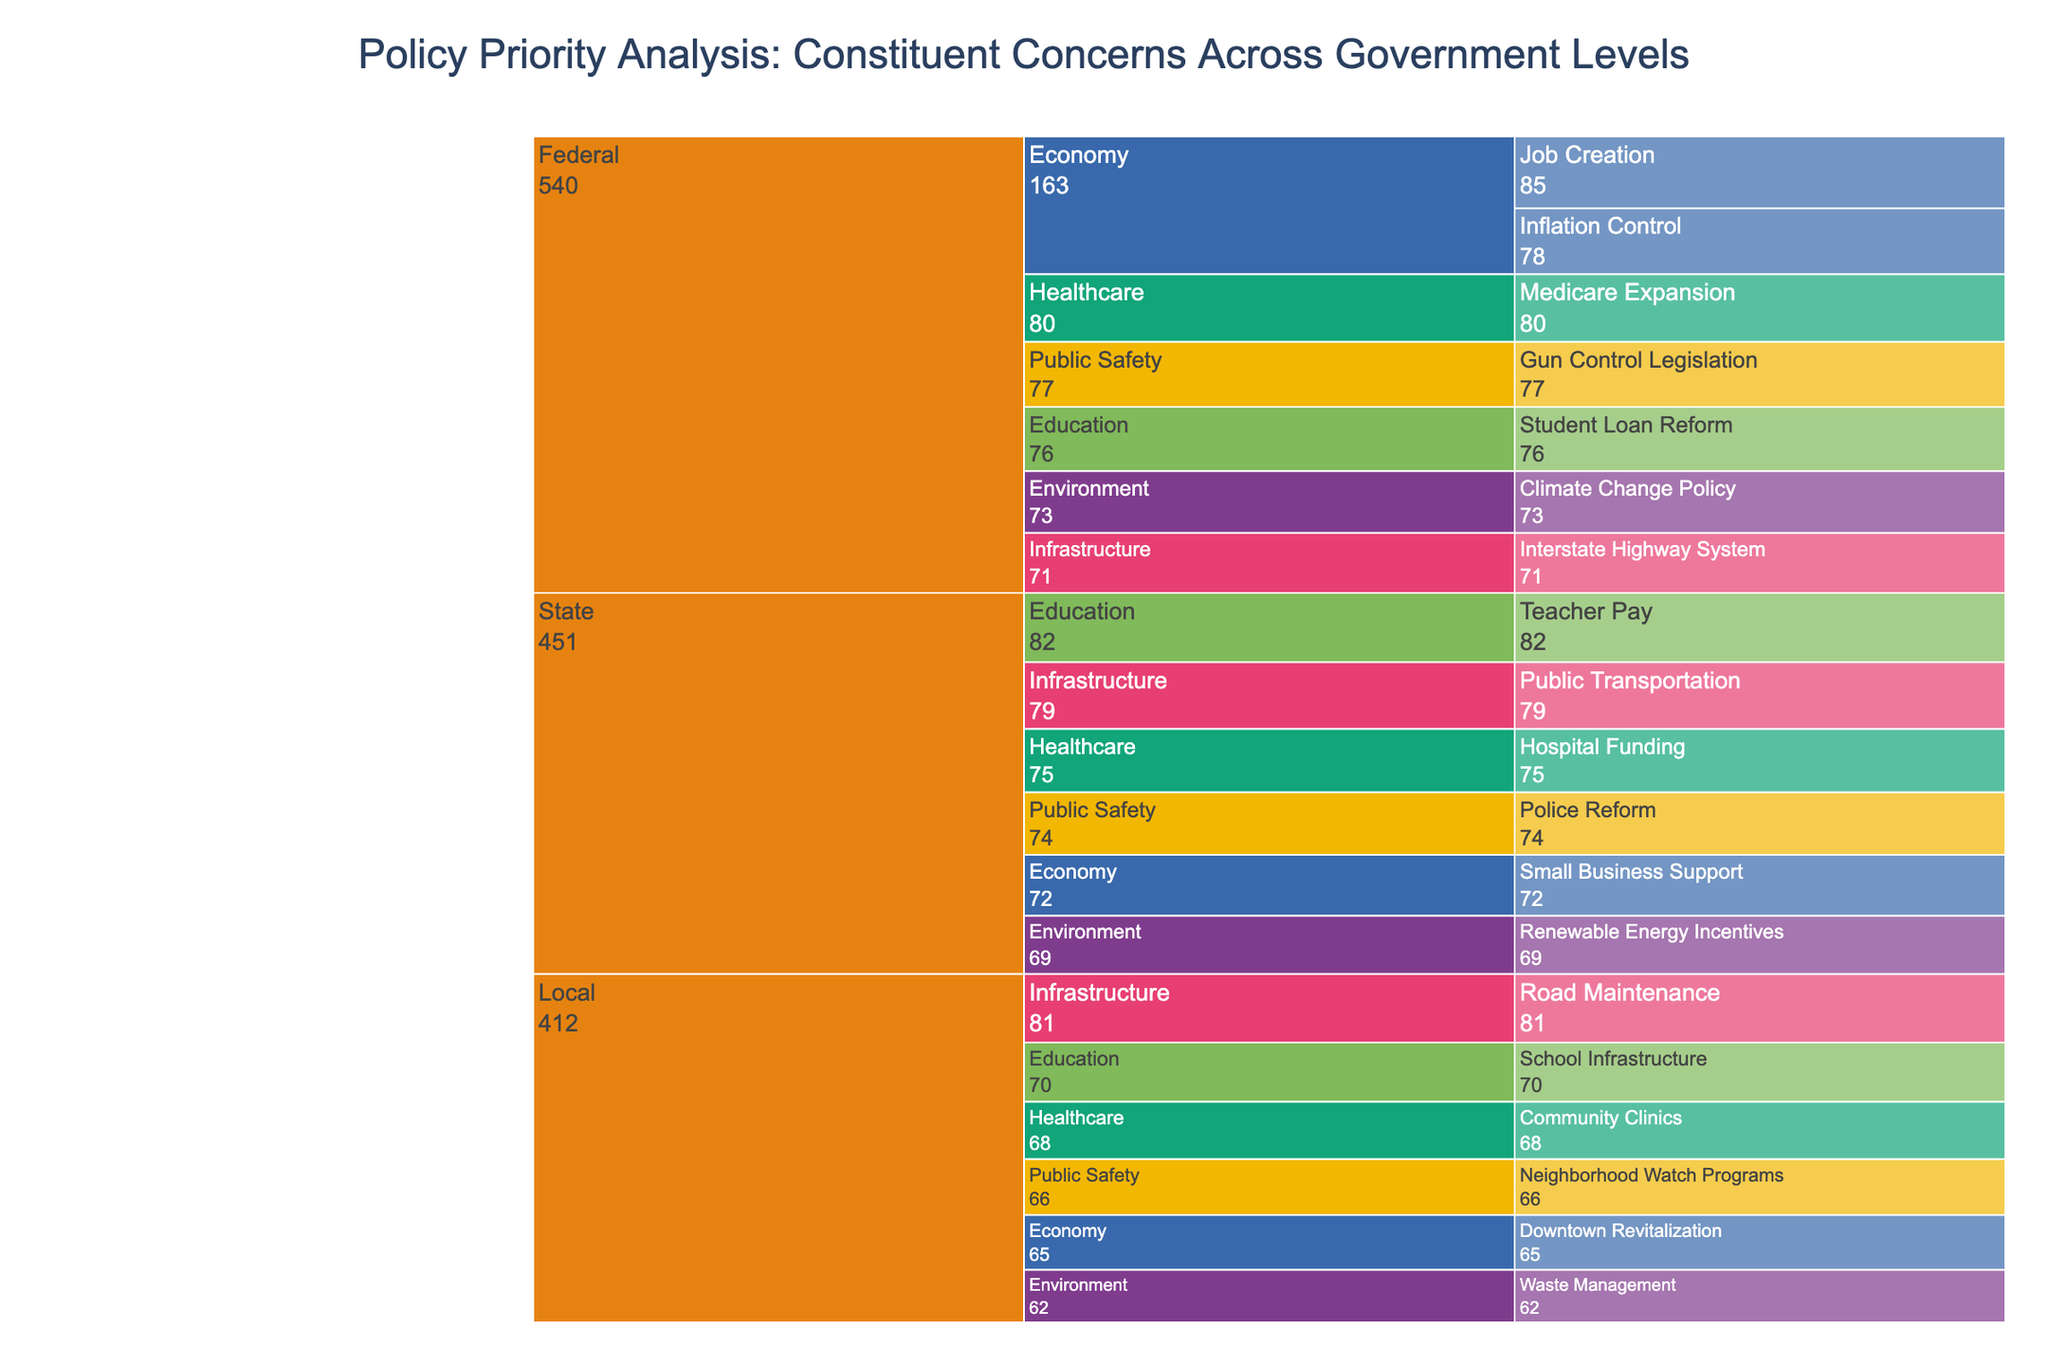What is the title of the chart? The title is usually displayed at the top of the chart. In this icicle chart, the title reads "Policy Priority Analysis: Constituent Concerns Across Government Levels".
Answer: Policy Priority Analysis: Constituent Concerns Across Government Levels Which policy area at the federal level has the highest importance score? Look under the "Federal" category and compare the importance scores. The "Economy" policy area with "Job Creation" has the highest score of 85.
Answer: Economy (Job Creation) What is the combined importance score for the local level under Healthcare? Add the importance scores for each specific concern under the local level for Healthcare. Here, it's "Community Clinics" with an importance score of 68.
Answer: 68 Which government level has the highest importance score for the Infrastructure policy area? Compare the importance scores for "Infrastructure" at the Federal, State, and Local levels. The local level "Road Maintenance" has the highest score of 81.
Answer: Local Which specific concern under the State level of Public Safety has a higher importance score? Under the state level of Public Safety, look for the specific concerns and their scores. "Police Reform" has an importance score of 74, with no other concerns under this category.
Answer: Police Reform What is the least important specific concern across the local government level? Compare the importance scores of all specific concerns at the local level. "Waste Management" under Environment has the lowest importance score of 62.
Answer: Waste Management Across all government levels, which policy area has the most total importance score for Healthcare? Sum the importance scores of all specific concerns under Healthcare across Federal (Medicare Expansion: 80), State (Hospital Funding: 75), and Local (Community Clinics: 68). The total is 80 + 75 + 68 = 223.
Answer: 223 Which policy area under the federal level shows higher concern: Education or Public Safety? Look at the importance scores for specific concerns under Education and Public Safety at the federal level. Education (Student Loan Reform: 76) and Public Safety (Gun Control Legislation: 77). Public Safety has a higher score.
Answer: Public Safety What is the average importance score for the Environment policy area across all government levels? Add the importance scores for each specific concern under Environment, then divide by the number of concerns. (73 (Federal) + 69 (State) + 62 (Local)) / 3 = 204 / 3 ≈ 68.
Answer: 68 How many unique policy areas are represented in the chart? Identify all unique policy areas listed: Economy, Healthcare, Education, Environment, Public Safety, Infrastructure. Count them, and there are 6 unique areas.
Answer: 6 